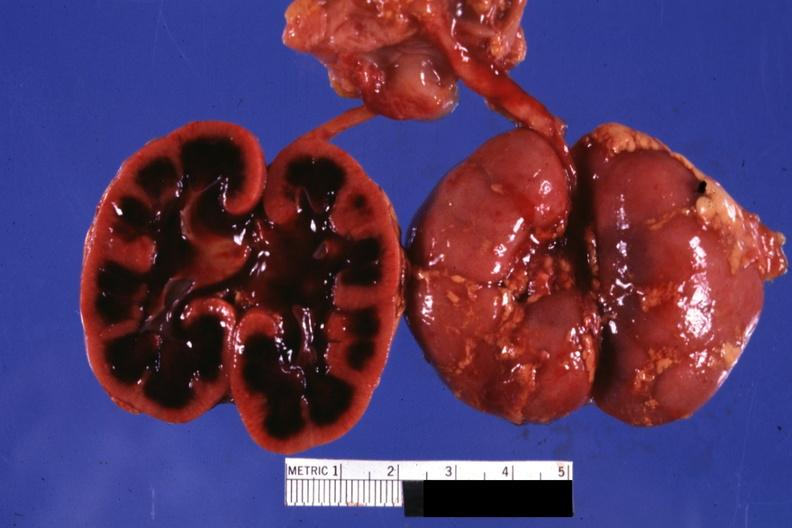does respiratory show typical cut surface appearance for severe ischemia?
Answer the question using a single word or phrase. No 